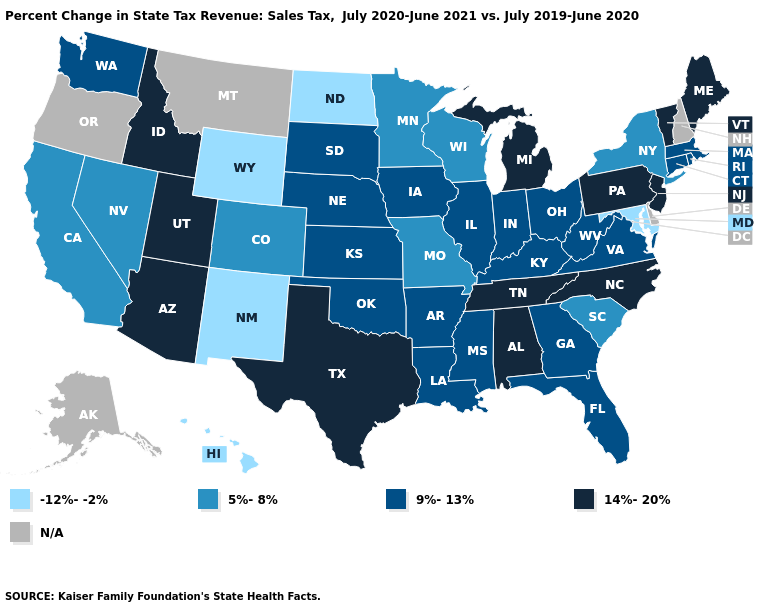Name the states that have a value in the range 14%-20%?
Quick response, please. Alabama, Arizona, Idaho, Maine, Michigan, New Jersey, North Carolina, Pennsylvania, Tennessee, Texas, Utah, Vermont. Is the legend a continuous bar?
Answer briefly. No. Among the states that border Arizona , which have the highest value?
Write a very short answer. Utah. What is the value of Michigan?
Answer briefly. 14%-20%. Name the states that have a value in the range 5%-8%?
Write a very short answer. California, Colorado, Minnesota, Missouri, Nevada, New York, South Carolina, Wisconsin. Does Virginia have the highest value in the USA?
Answer briefly. No. Name the states that have a value in the range N/A?
Short answer required. Alaska, Delaware, Montana, New Hampshire, Oregon. Name the states that have a value in the range N/A?
Concise answer only. Alaska, Delaware, Montana, New Hampshire, Oregon. What is the value of Alabama?
Write a very short answer. 14%-20%. What is the highest value in the West ?
Quick response, please. 14%-20%. What is the value of Pennsylvania?
Answer briefly. 14%-20%. Does the first symbol in the legend represent the smallest category?
Write a very short answer. Yes. Among the states that border Rhode Island , which have the highest value?
Be succinct. Connecticut, Massachusetts. What is the value of North Carolina?
Concise answer only. 14%-20%. Does Michigan have the highest value in the MidWest?
Be succinct. Yes. 